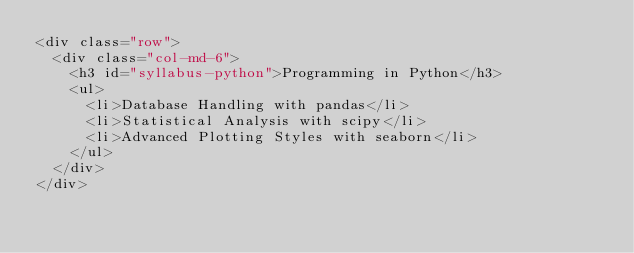Convert code to text. <code><loc_0><loc_0><loc_500><loc_500><_HTML_><div class="row">
  <div class="col-md-6">
    <h3 id="syllabus-python">Programming in Python</h3>
    <ul>
      <li>Database Handling with pandas</li>
      <li>Statistical Analysis with scipy</li>
      <li>Advanced Plotting Styles with seaborn</li>
    </ul>
  </div>
</div>
</code> 